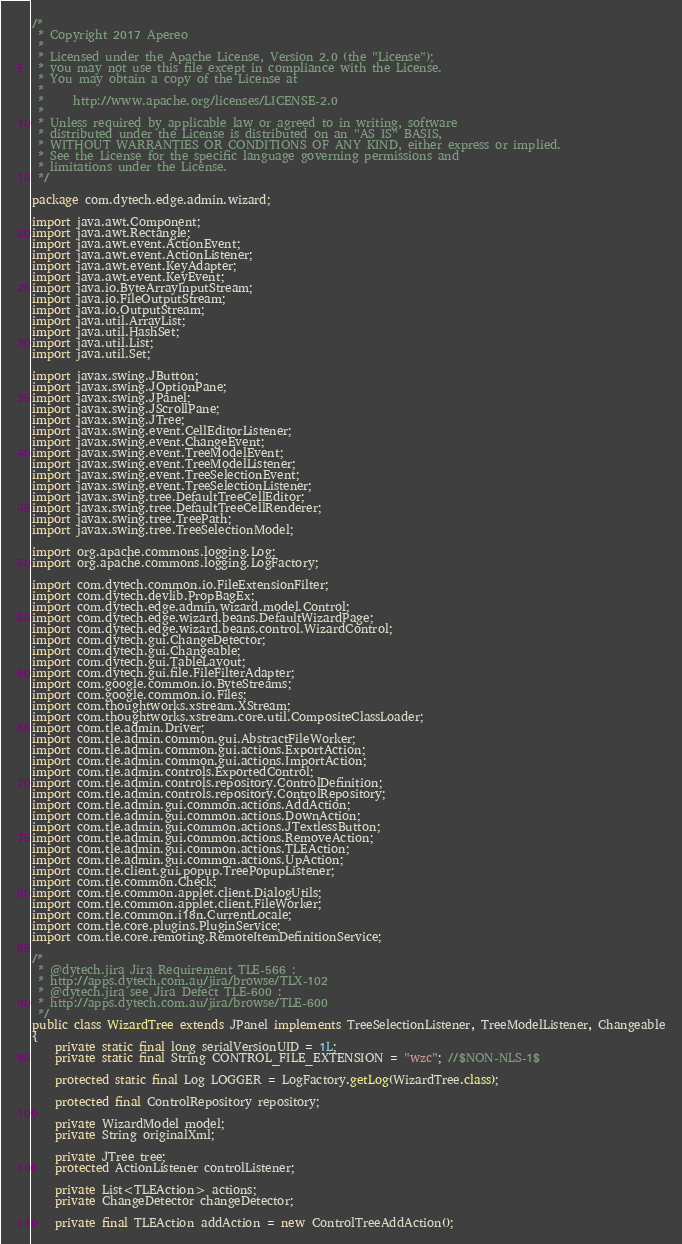<code> <loc_0><loc_0><loc_500><loc_500><_Java_>/*
 * Copyright 2017 Apereo
 *
 * Licensed under the Apache License, Version 2.0 (the "License");
 * you may not use this file except in compliance with the License.
 * You may obtain a copy of the License at
 *
 *     http://www.apache.org/licenses/LICENSE-2.0
 *
 * Unless required by applicable law or agreed to in writing, software
 * distributed under the License is distributed on an "AS IS" BASIS,
 * WITHOUT WARRANTIES OR CONDITIONS OF ANY KIND, either express or implied.
 * See the License for the specific language governing permissions and
 * limitations under the License.
 */

package com.dytech.edge.admin.wizard;

import java.awt.Component;
import java.awt.Rectangle;
import java.awt.event.ActionEvent;
import java.awt.event.ActionListener;
import java.awt.event.KeyAdapter;
import java.awt.event.KeyEvent;
import java.io.ByteArrayInputStream;
import java.io.FileOutputStream;
import java.io.OutputStream;
import java.util.ArrayList;
import java.util.HashSet;
import java.util.List;
import java.util.Set;

import javax.swing.JButton;
import javax.swing.JOptionPane;
import javax.swing.JPanel;
import javax.swing.JScrollPane;
import javax.swing.JTree;
import javax.swing.event.CellEditorListener;
import javax.swing.event.ChangeEvent;
import javax.swing.event.TreeModelEvent;
import javax.swing.event.TreeModelListener;
import javax.swing.event.TreeSelectionEvent;
import javax.swing.event.TreeSelectionListener;
import javax.swing.tree.DefaultTreeCellEditor;
import javax.swing.tree.DefaultTreeCellRenderer;
import javax.swing.tree.TreePath;
import javax.swing.tree.TreeSelectionModel;

import org.apache.commons.logging.Log;
import org.apache.commons.logging.LogFactory;

import com.dytech.common.io.FileExtensionFilter;
import com.dytech.devlib.PropBagEx;
import com.dytech.edge.admin.wizard.model.Control;
import com.dytech.edge.wizard.beans.DefaultWizardPage;
import com.dytech.edge.wizard.beans.control.WizardControl;
import com.dytech.gui.ChangeDetector;
import com.dytech.gui.Changeable;
import com.dytech.gui.TableLayout;
import com.dytech.gui.file.FileFilterAdapter;
import com.google.common.io.ByteStreams;
import com.google.common.io.Files;
import com.thoughtworks.xstream.XStream;
import com.thoughtworks.xstream.core.util.CompositeClassLoader;
import com.tle.admin.Driver;
import com.tle.admin.common.gui.AbstractFileWorker;
import com.tle.admin.common.gui.actions.ExportAction;
import com.tle.admin.common.gui.actions.ImportAction;
import com.tle.admin.controls.ExportedControl;
import com.tle.admin.controls.repository.ControlDefinition;
import com.tle.admin.controls.repository.ControlRepository;
import com.tle.admin.gui.common.actions.AddAction;
import com.tle.admin.gui.common.actions.DownAction;
import com.tle.admin.gui.common.actions.JTextlessButton;
import com.tle.admin.gui.common.actions.RemoveAction;
import com.tle.admin.gui.common.actions.TLEAction;
import com.tle.admin.gui.common.actions.UpAction;
import com.tle.client.gui.popup.TreePopupListener;
import com.tle.common.Check;
import com.tle.common.applet.client.DialogUtils;
import com.tle.common.applet.client.FileWorker;
import com.tle.common.i18n.CurrentLocale;
import com.tle.core.plugins.PluginService;
import com.tle.core.remoting.RemoteItemDefinitionService;

/*
 * @dytech.jira Jira Requirement TLE-566 :
 * http://apps.dytech.com.au/jira/browse/TLX-102
 * @dytech.jira see Jira Defect TLE-600 :
 * http://apps.dytech.com.au/jira/browse/TLE-600
 */
public class WizardTree extends JPanel implements TreeSelectionListener, TreeModelListener, Changeable
{
	private static final long serialVersionUID = 1L;
	private static final String CONTROL_FILE_EXTENSION = "wzc"; //$NON-NLS-1$

	protected static final Log LOGGER = LogFactory.getLog(WizardTree.class);

	protected final ControlRepository repository;

	private WizardModel model;
	private String originalXml;

	private JTree tree;
	protected ActionListener controlListener;

	private List<TLEAction> actions;
	private ChangeDetector changeDetector;

	private final TLEAction addAction = new ControlTreeAddAction();</code> 